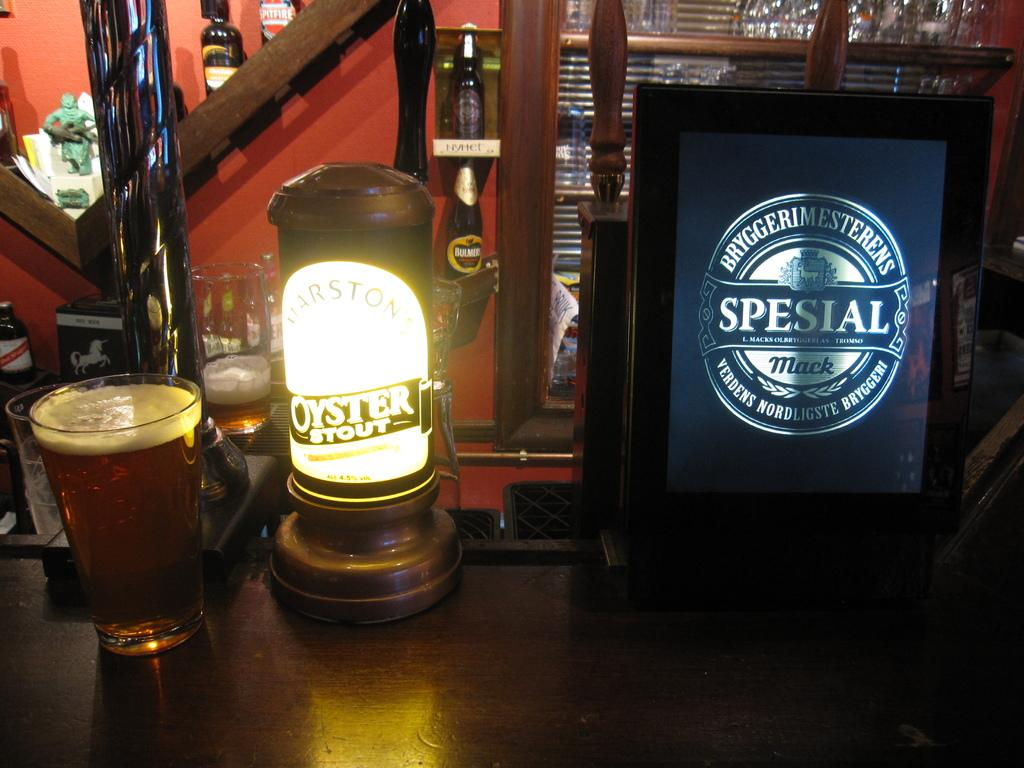Provide a one-sentence caption for the provided image. a glass of beer next to a pump advertising Oyster stout. 